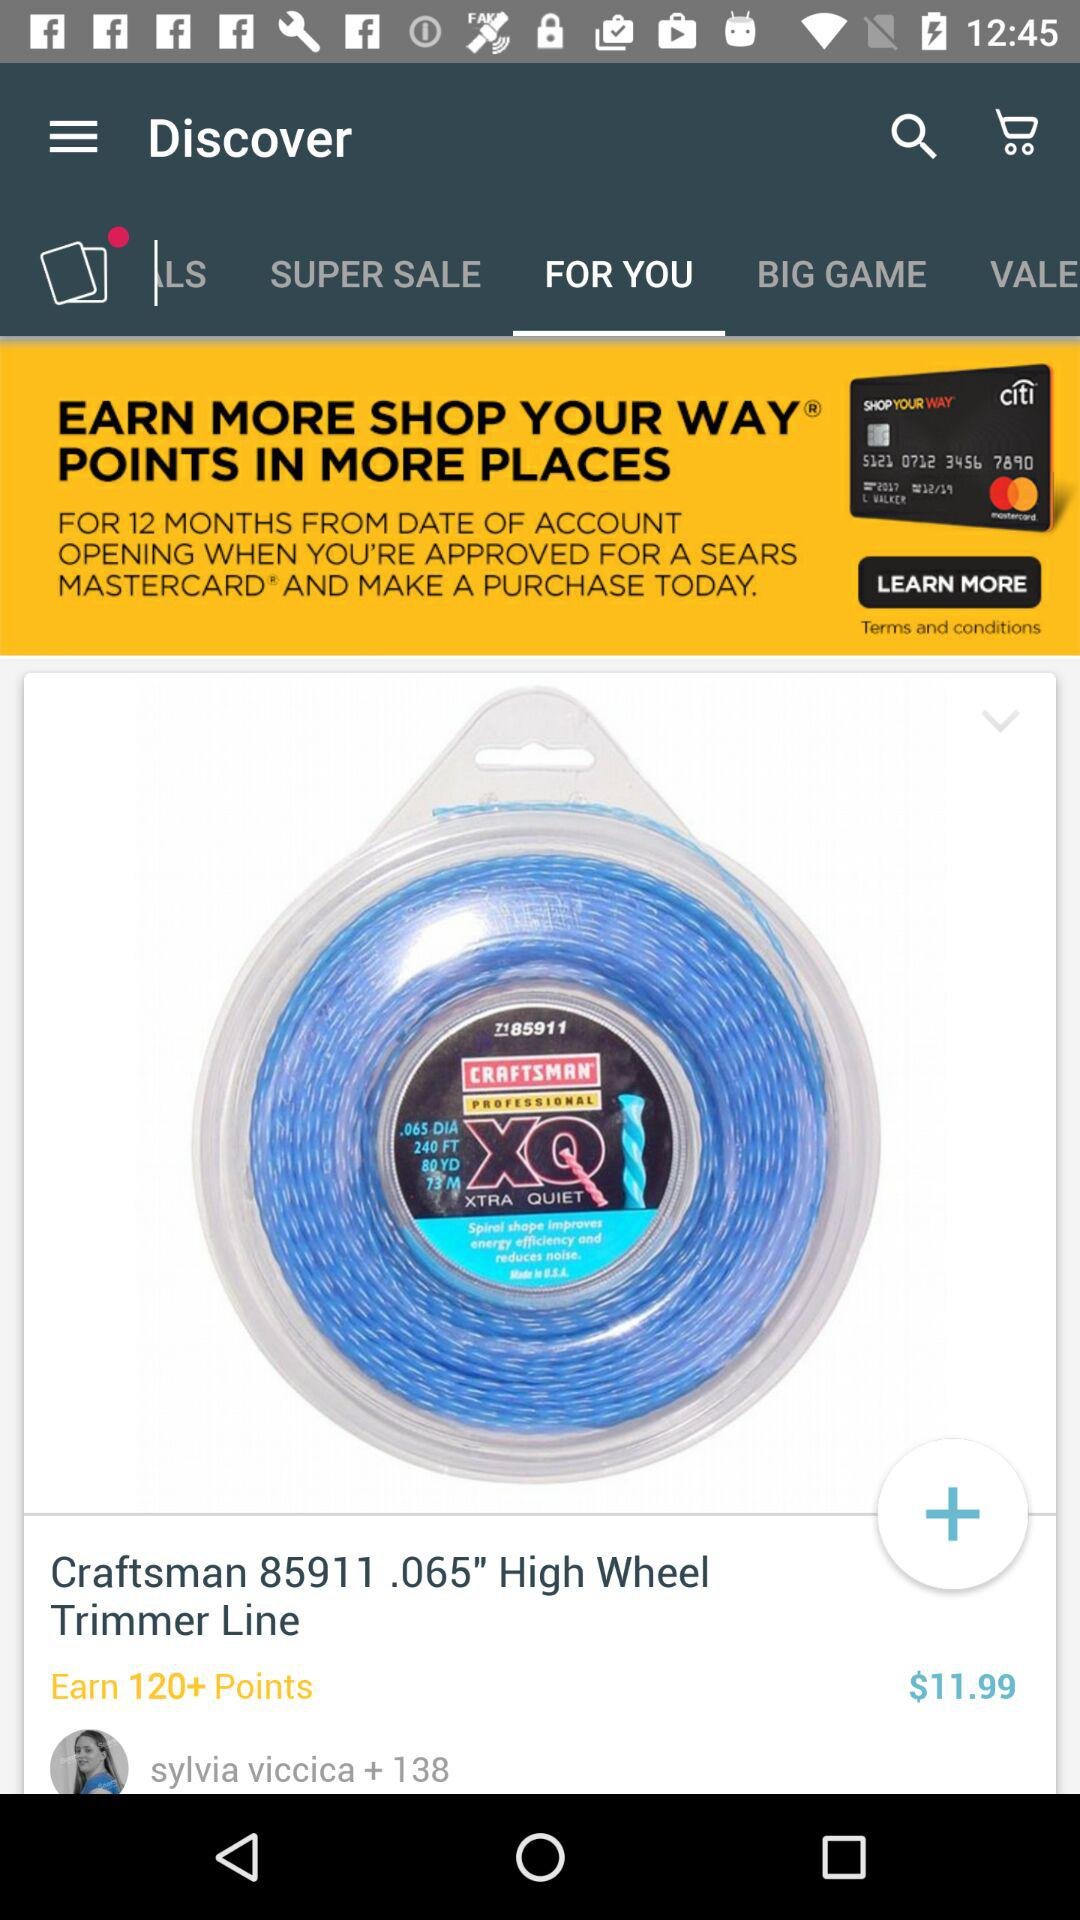What is the selected tab? The selected tab is "FOR YOU". 